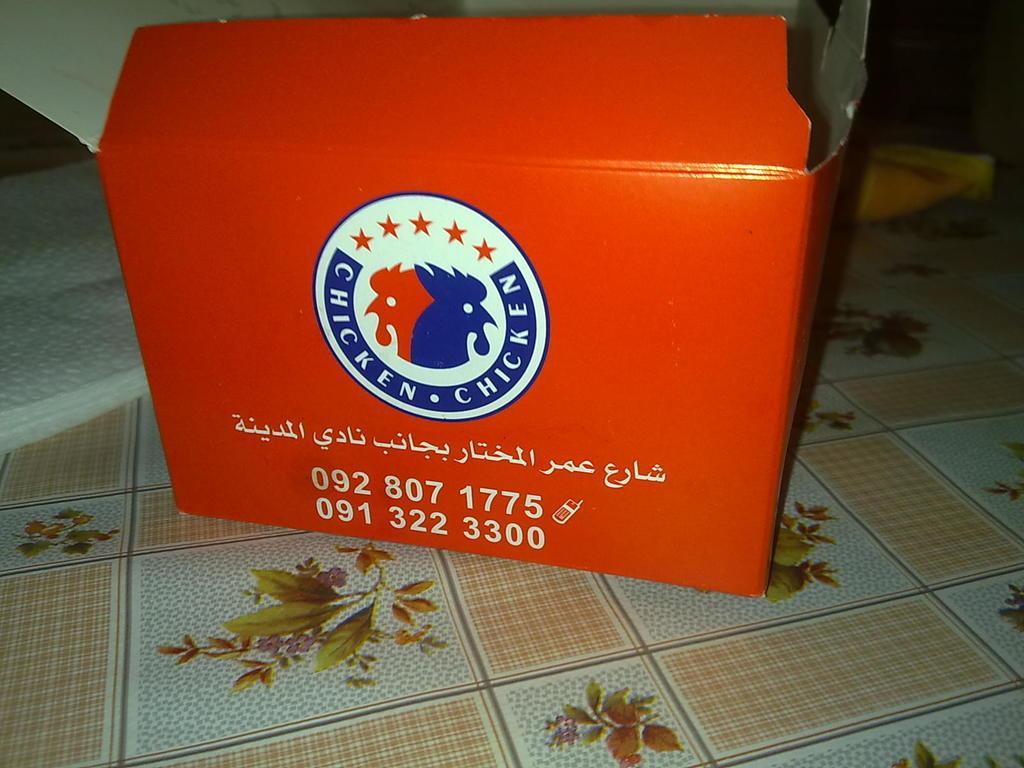What is the second phone number?
Give a very brief answer. 091 322 3300. What is the first phone number?
Make the answer very short. 092 807 1775. 